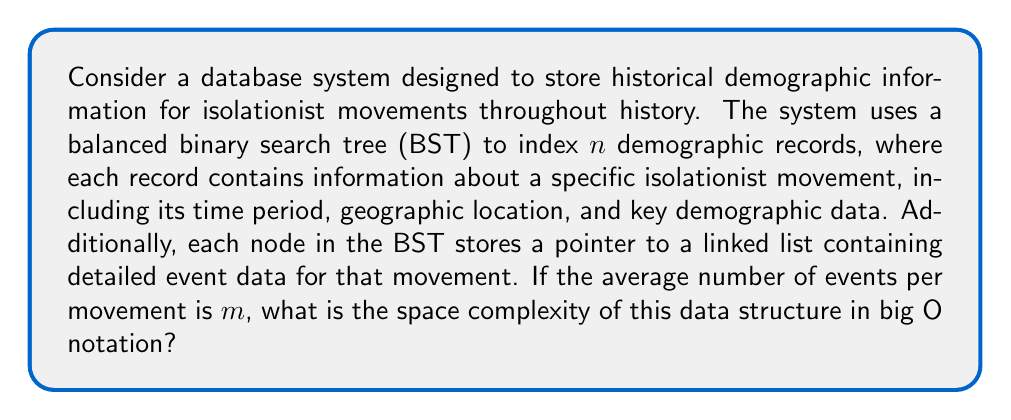Could you help me with this problem? To determine the space complexity of this data structure, we need to consider the space required by both the binary search tree and the linked lists:

1. Binary Search Tree (BST):
   - A balanced BST with $n$ nodes requires $O(n)$ space.
   - Each node in the BST contains:
     a) A key (e.g., movement identifier)
     b) Demographic data (constant size per record)
     c) Pointers to left and right children
     d) A pointer to the linked list of events

   The space complexity for the BST alone is $O(n)$.

2. Linked Lists:
   - There are $n$ linked lists, one for each movement.
   - On average, each linked list contains $m$ events.
   - Each event node in the linked list stores event data and a pointer to the next node.

   The total space for all linked lists is $O(n \cdot m)$.

3. Total Space Complexity:
   - Combining the space requirements for the BST and the linked lists:
     $$O(n) + O(n \cdot m) = O(n + nm)$$

   - Since $m$ represents the average number of events per movement, it can be considered a constant factor if we assume it doesn't grow with $n$.
   - However, in the worst-case scenario where $m$ could potentially grow with $n$, we keep it as a separate factor.

Therefore, the overall space complexity of this data structure is $O(n + nm)$.
Answer: $O(n + nm)$ 